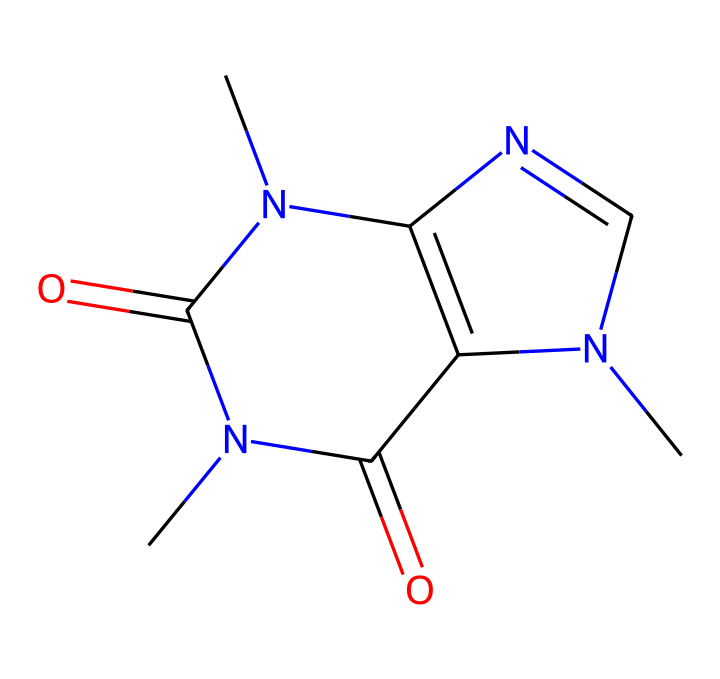How many nitrogen atoms are present in this chemical? By examining the SMILES representation, there are three nitrogen atoms (N) indicated in the structure. Each nitrogen corresponds to a N symbol in the SMILES.
Answer: three What is the primary functional group present in this chemical? The chemical structure contains multiple carbonyl groups (C=O); however, since the primary effect associates with the amine guide leading to its stimulant properties, we identify the amine as the primary functional importance.
Answer: amine What is the molecular weight of caffeine? The molecular formula derived from the SMILES representation is C8H10N4O2. Calculating its molecular weight using the atomic weights (C=12, H=1, N=14, O=16) gives us 194.19 g/mol.
Answer: 194.19 Which part of this chemical structure contributes to its psychoactive effects? The nitrogen atoms within the cycle structure are responsible for its interaction with adenosine receptors in the brain, leading to stimulant effects. The entire structure's cyclic nature also plays a role.
Answer: nitrogen atoms How does the presence of carbonyl groups influence caffeine's solubility? Carbonyl groups increase polarity due to their electronegativity, enhancing solubility in polar solvents like water; hence, caffeine dissolves well, which is crucial for its biological activity.
Answer: increases solubility 